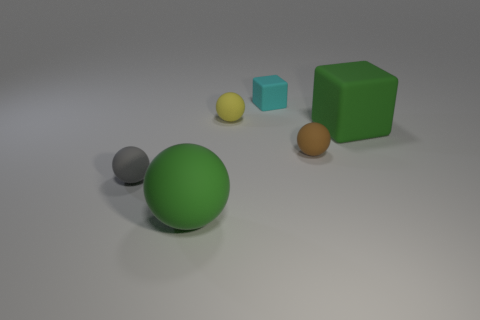Add 3 gray metal cubes. How many objects exist? 9 Subtract all cubes. How many objects are left? 4 Add 6 tiny rubber spheres. How many tiny rubber spheres exist? 9 Subtract 0 red blocks. How many objects are left? 6 Subtract all small cyan cylinders. Subtract all small gray rubber objects. How many objects are left? 5 Add 4 brown rubber objects. How many brown rubber objects are left? 5 